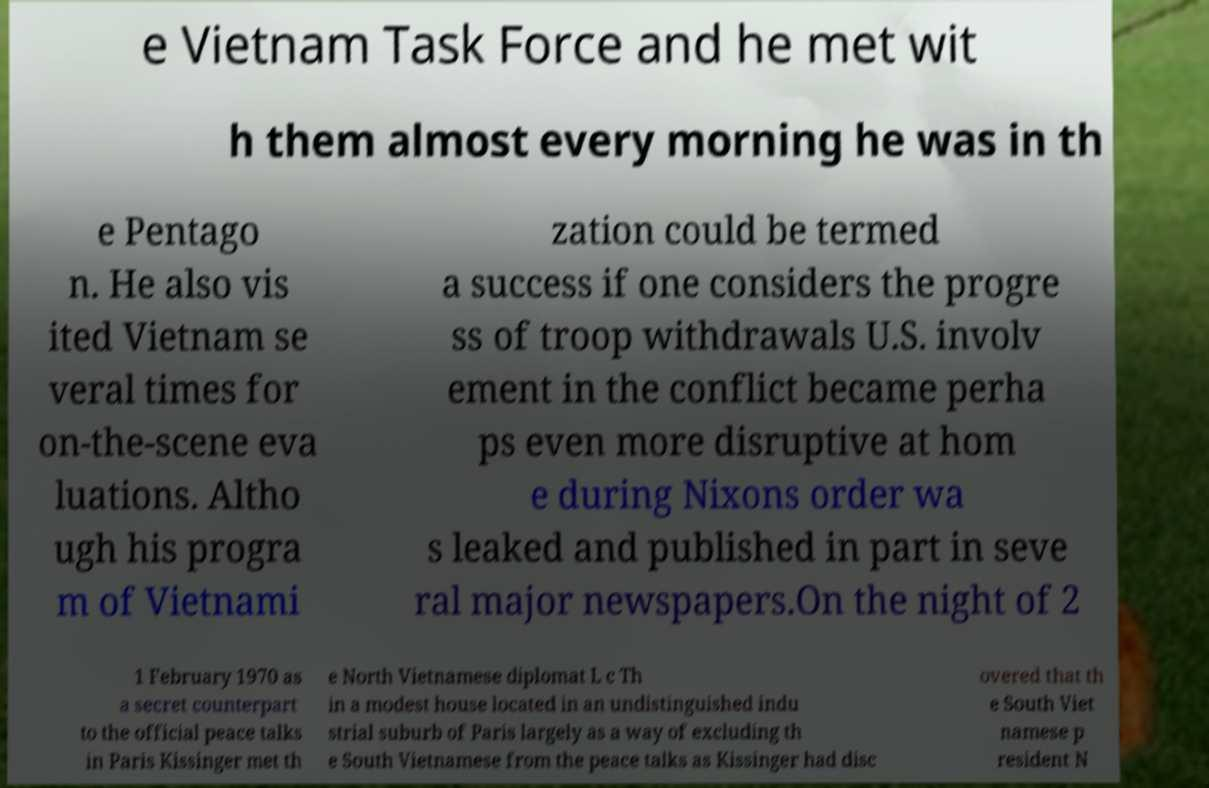Can you read and provide the text displayed in the image?This photo seems to have some interesting text. Can you extract and type it out for me? e Vietnam Task Force and he met wit h them almost every morning he was in th e Pentago n. He also vis ited Vietnam se veral times for on-the-scene eva luations. Altho ugh his progra m of Vietnami zation could be termed a success if one considers the progre ss of troop withdrawals U.S. involv ement in the conflict became perha ps even more disruptive at hom e during Nixons order wa s leaked and published in part in seve ral major newspapers.On the night of 2 1 February 1970 as a secret counterpart to the official peace talks in Paris Kissinger met th e North Vietnamese diplomat L c Th in a modest house located in an undistinguished indu strial suburb of Paris largely as a way of excluding th e South Vietnamese from the peace talks as Kissinger had disc overed that th e South Viet namese p resident N 